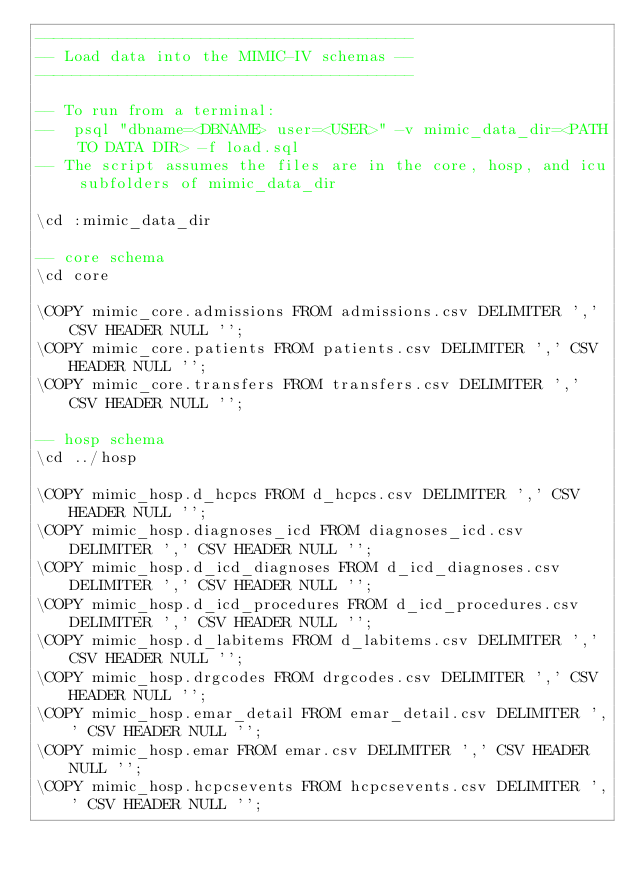<code> <loc_0><loc_0><loc_500><loc_500><_SQL_>-----------------------------------------
-- Load data into the MIMIC-IV schemas --
-----------------------------------------

-- To run from a terminal:
--  psql "dbname=<DBNAME> user=<USER>" -v mimic_data_dir=<PATH TO DATA DIR> -f load.sql
-- The script assumes the files are in the core, hosp, and icu subfolders of mimic_data_dir

\cd :mimic_data_dir

-- core schema
\cd core

\COPY mimic_core.admissions FROM admissions.csv DELIMITER ',' CSV HEADER NULL '';
\COPY mimic_core.patients FROM patients.csv DELIMITER ',' CSV HEADER NULL '';
\COPY mimic_core.transfers FROM transfers.csv DELIMITER ',' CSV HEADER NULL '';

-- hosp schema
\cd ../hosp

\COPY mimic_hosp.d_hcpcs FROM d_hcpcs.csv DELIMITER ',' CSV HEADER NULL '';
\COPY mimic_hosp.diagnoses_icd FROM diagnoses_icd.csv DELIMITER ',' CSV HEADER NULL '';
\COPY mimic_hosp.d_icd_diagnoses FROM d_icd_diagnoses.csv DELIMITER ',' CSV HEADER NULL '';
\COPY mimic_hosp.d_icd_procedures FROM d_icd_procedures.csv DELIMITER ',' CSV HEADER NULL '';
\COPY mimic_hosp.d_labitems FROM d_labitems.csv DELIMITER ',' CSV HEADER NULL '';
\COPY mimic_hosp.drgcodes FROM drgcodes.csv DELIMITER ',' CSV HEADER NULL '';
\COPY mimic_hosp.emar_detail FROM emar_detail.csv DELIMITER ',' CSV HEADER NULL '';
\COPY mimic_hosp.emar FROM emar.csv DELIMITER ',' CSV HEADER NULL '';
\COPY mimic_hosp.hcpcsevents FROM hcpcsevents.csv DELIMITER ',' CSV HEADER NULL '';</code> 